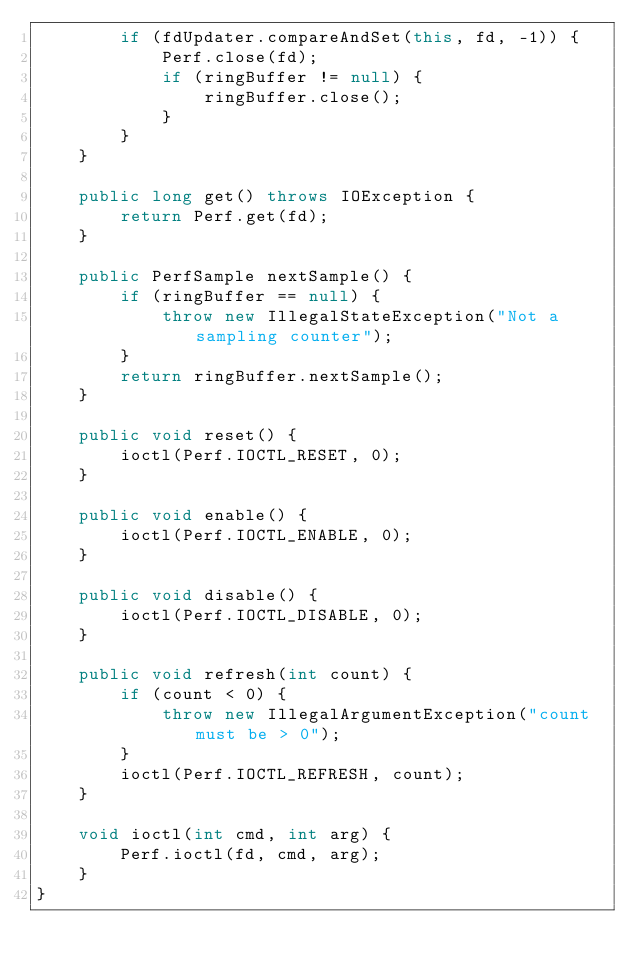<code> <loc_0><loc_0><loc_500><loc_500><_Java_>        if (fdUpdater.compareAndSet(this, fd, -1)) {
            Perf.close(fd);
            if (ringBuffer != null) {
                ringBuffer.close();
            }
        }
    }

    public long get() throws IOException {
        return Perf.get(fd);
    }

    public PerfSample nextSample() {
        if (ringBuffer == null) {
            throw new IllegalStateException("Not a sampling counter");
        }
        return ringBuffer.nextSample();
    }

    public void reset() {
        ioctl(Perf.IOCTL_RESET, 0);
    }

    public void enable() {
        ioctl(Perf.IOCTL_ENABLE, 0);
    }

    public void disable() {
        ioctl(Perf.IOCTL_DISABLE, 0);
    }

    public void refresh(int count) {
        if (count < 0) {
            throw new IllegalArgumentException("count must be > 0");
        }
        ioctl(Perf.IOCTL_REFRESH, count);
    }

    void ioctl(int cmd, int arg) {
        Perf.ioctl(fd, cmd, arg);
    }
}
</code> 